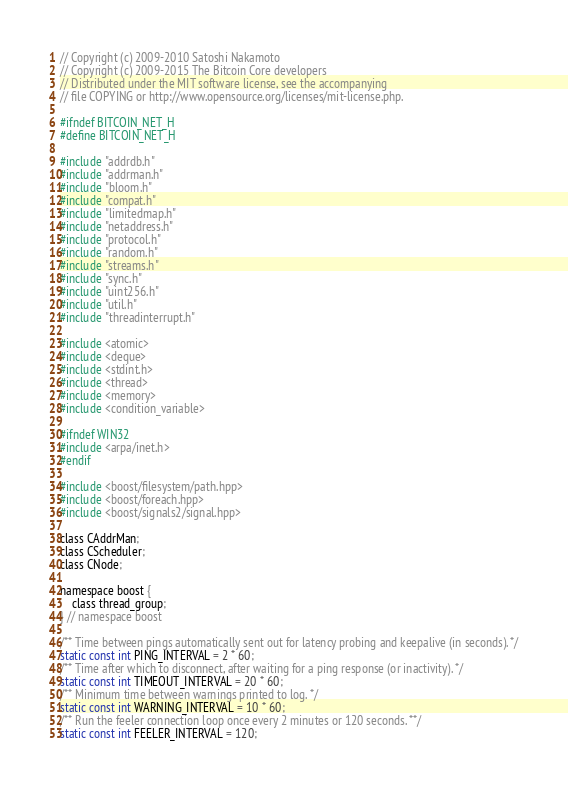<code> <loc_0><loc_0><loc_500><loc_500><_C_>// Copyright (c) 2009-2010 Satoshi Nakamoto
// Copyright (c) 2009-2015 The Bitcoin Core developers
// Distributed under the MIT software license, see the accompanying
// file COPYING or http://www.opensource.org/licenses/mit-license.php.

#ifndef BITCOIN_NET_H
#define BITCOIN_NET_H

#include "addrdb.h"
#include "addrman.h"
#include "bloom.h"
#include "compat.h"
#include "limitedmap.h"
#include "netaddress.h"
#include "protocol.h"
#include "random.h"
#include "streams.h"
#include "sync.h"
#include "uint256.h"
#include "util.h"
#include "threadinterrupt.h"

#include <atomic>
#include <deque>
#include <stdint.h>
#include <thread>
#include <memory>
#include <condition_variable>

#ifndef WIN32
#include <arpa/inet.h>
#endif

#include <boost/filesystem/path.hpp>
#include <boost/foreach.hpp>
#include <boost/signals2/signal.hpp>

class CAddrMan;
class CScheduler;
class CNode;

namespace boost {
    class thread_group;
} // namespace boost

/** Time between pings automatically sent out for latency probing and keepalive (in seconds). */
static const int PING_INTERVAL = 2 * 60;
/** Time after which to disconnect, after waiting for a ping response (or inactivity). */
static const int TIMEOUT_INTERVAL = 20 * 60;
/** Minimum time between warnings printed to log. */
static const int WARNING_INTERVAL = 10 * 60;
/** Run the feeler connection loop once every 2 minutes or 120 seconds. **/
static const int FEELER_INTERVAL = 120;</code> 